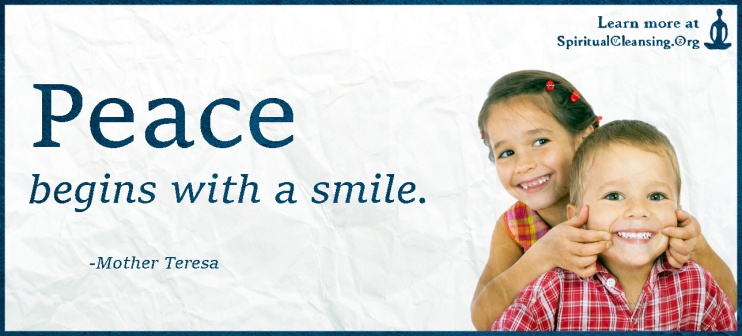Imagine the children in the photo could talk to future generations. What message would they leave? If the children in the photo could speak to future generations, their message might revolve around the enduring power of kindness, joy, and human connection. They could say, 'Always remember the power of a smile. It's a simple gesture that can make a big difference in someone's day. Be kind to yourself and others, cherish your friendships, and never forget to play and laugh. Life has its challenges, but with a smile and kindness, we can create a world full of peace and happiness. Carry this message in your hearts, and spread it wherever you go.' Once, in a future where the scars of history had become lessons rather than burdens, a message echoed through generations. It began with two children, their laughter caught forever in a photograph, a beacon of simplicity and joy. They spoke through the ages: 'To those who come after us, we want you to know that peace isn't just an idea; it's a practice. It's in the way you greet the dawn, in the kindness you show to those you meet, and in the love you cultivate in your hearts. Whenever you feel lost, remember to smile and look for the good in others. Every smile, every act of kindness, is a stone cast in the river of life, sending ripples that touch shores far beyond your sight. This will be your legacy, a world knitted together by kindness, where peace begins and ends with the smile on your faces.' 